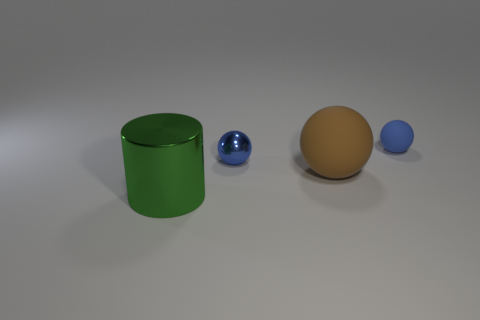What number of things are either blue balls that are in front of the blue matte thing or large brown balls?
Your response must be concise. 2. The brown matte thing that is the same shape as the blue shiny thing is what size?
Give a very brief answer. Large. There is a metallic thing that is on the right side of the big metal object; is its shape the same as the large object right of the big cylinder?
Your answer should be compact. Yes. There is a shiny ball; does it have the same size as the sphere that is in front of the metallic ball?
Give a very brief answer. No. What number of other things are the same material as the big brown ball?
Ensure brevity in your answer.  1. Is there any other thing that has the same shape as the big green shiny thing?
Offer a terse response. No. The thing that is on the right side of the big object that is on the right side of the large metallic object that is in front of the blue metal object is what color?
Give a very brief answer. Blue. What shape is the object that is both to the right of the big metal object and left of the large rubber sphere?
Make the answer very short. Sphere. What color is the large cylinder in front of the blue matte thing that is behind the big brown object?
Your answer should be compact. Green. What is the shape of the tiny object behind the shiny object that is on the right side of the object on the left side of the tiny metal thing?
Offer a very short reply. Sphere. 